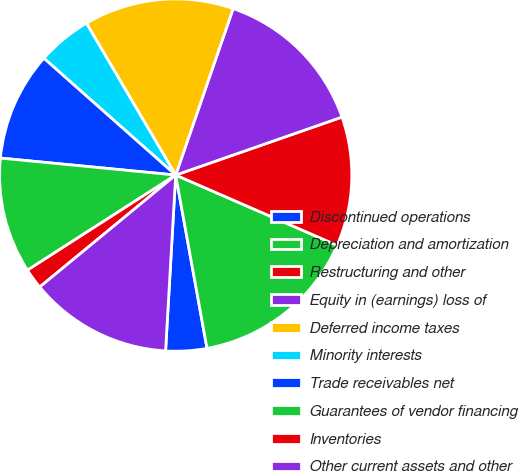<chart> <loc_0><loc_0><loc_500><loc_500><pie_chart><fcel>Discontinued operations<fcel>Depreciation and amortization<fcel>Restructuring and other<fcel>Equity in (earnings) loss of<fcel>Deferred income taxes<fcel>Minority interests<fcel>Trade receivables net<fcel>Guarantees of vendor financing<fcel>Inventories<fcel>Other current assets and other<nl><fcel>3.76%<fcel>15.62%<fcel>11.87%<fcel>14.37%<fcel>13.75%<fcel>5.0%<fcel>10.0%<fcel>10.62%<fcel>1.88%<fcel>13.12%<nl></chart> 